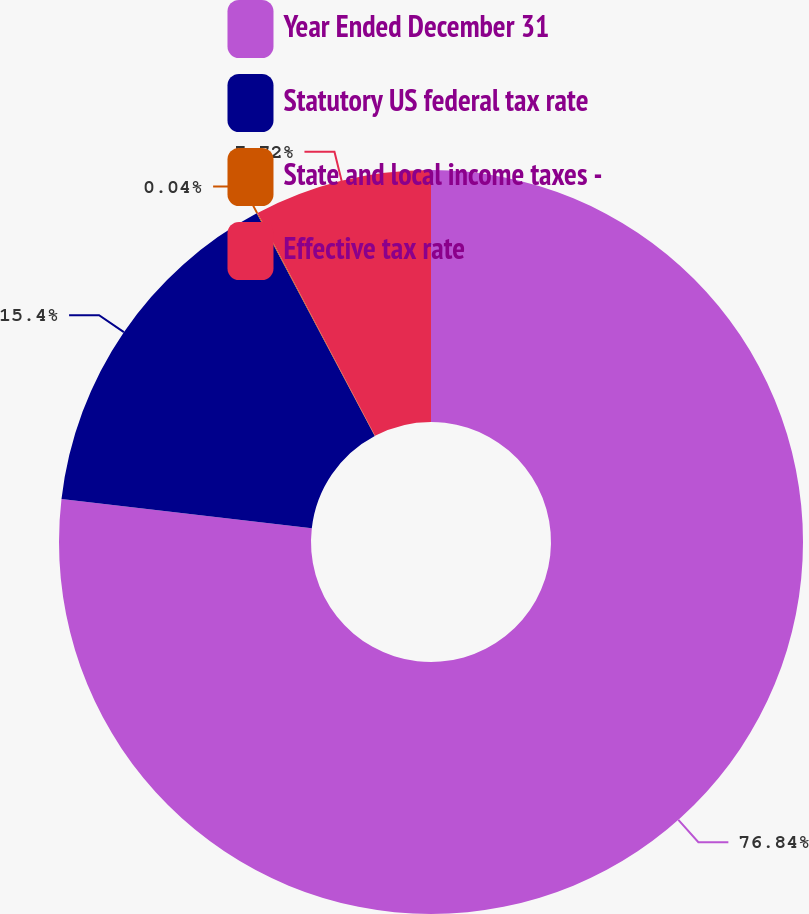Convert chart to OTSL. <chart><loc_0><loc_0><loc_500><loc_500><pie_chart><fcel>Year Ended December 31<fcel>Statutory US federal tax rate<fcel>State and local income taxes -<fcel>Effective tax rate<nl><fcel>76.84%<fcel>15.4%<fcel>0.04%<fcel>7.72%<nl></chart> 